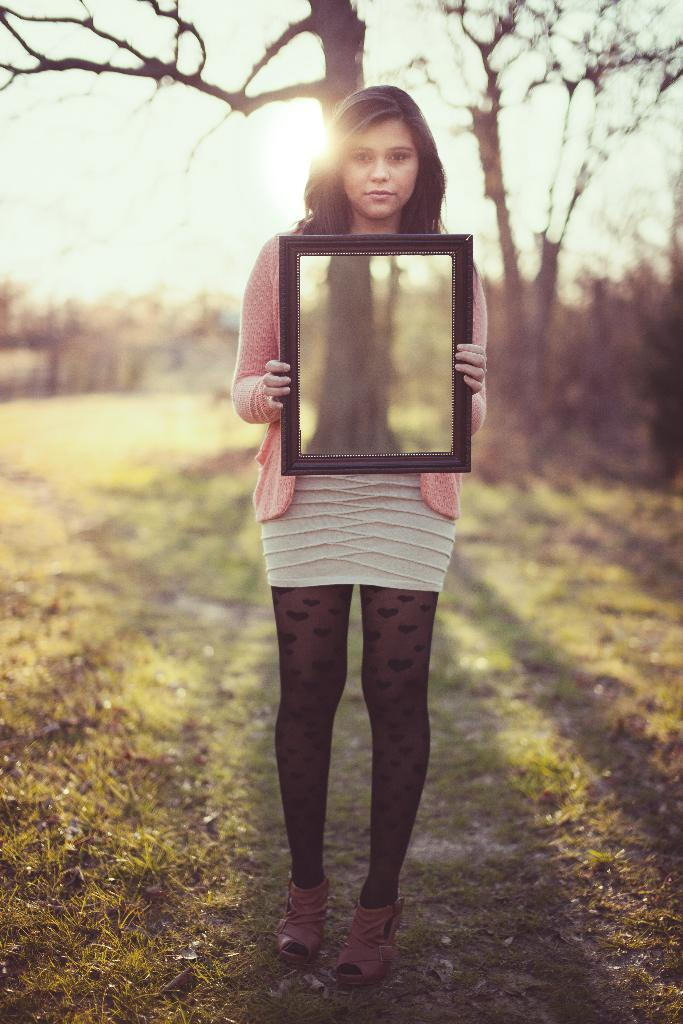What can be observed about the background of the image? The background of the image is blurred. What type of tree is visible in the image? There is a bare tree in the image. Who is present in the image? There is a woman standing in the image. What is the woman holding in her hand? The woman is holding an object in her hand. How many cats are on the ship in the image? There is no ship or cats present in the image. What type of thrill can be experienced by the woman in the image? The image does not provide information about any thrilling experiences; it only shows a woman standing with an object in her hand. 